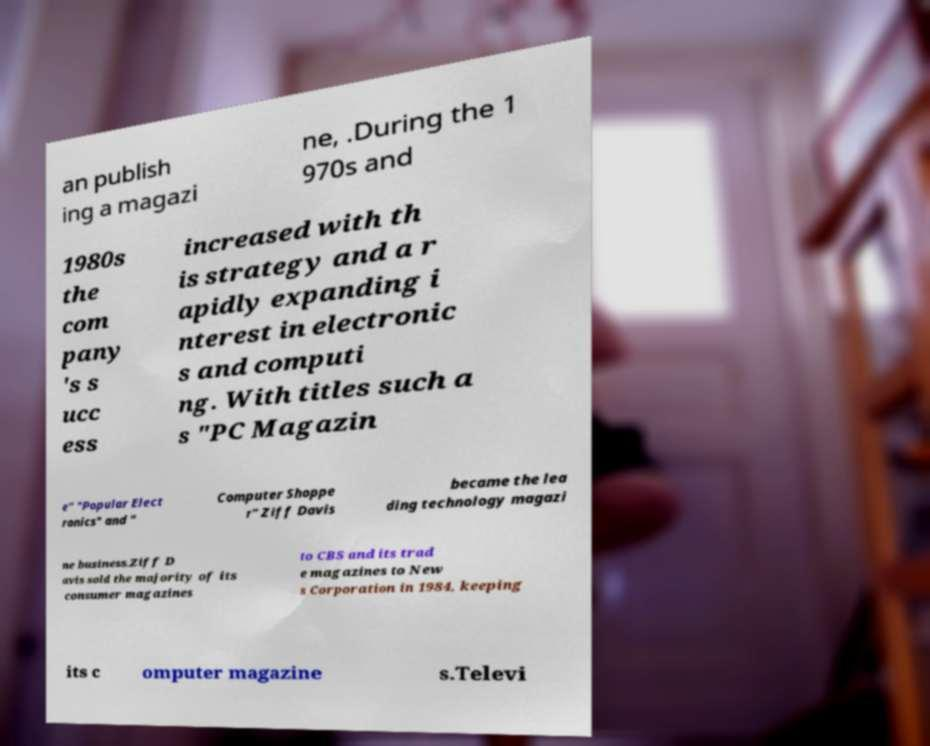Can you read and provide the text displayed in the image?This photo seems to have some interesting text. Can you extract and type it out for me? an publish ing a magazi ne, .During the 1 970s and 1980s the com pany 's s ucc ess increased with th is strategy and a r apidly expanding i nterest in electronic s and computi ng. With titles such a s "PC Magazin e" "Popular Elect ronics" and " Computer Shoppe r" Ziff Davis became the lea ding technology magazi ne business.Ziff D avis sold the majority of its consumer magazines to CBS and its trad e magazines to New s Corporation in 1984, keeping its c omputer magazine s.Televi 